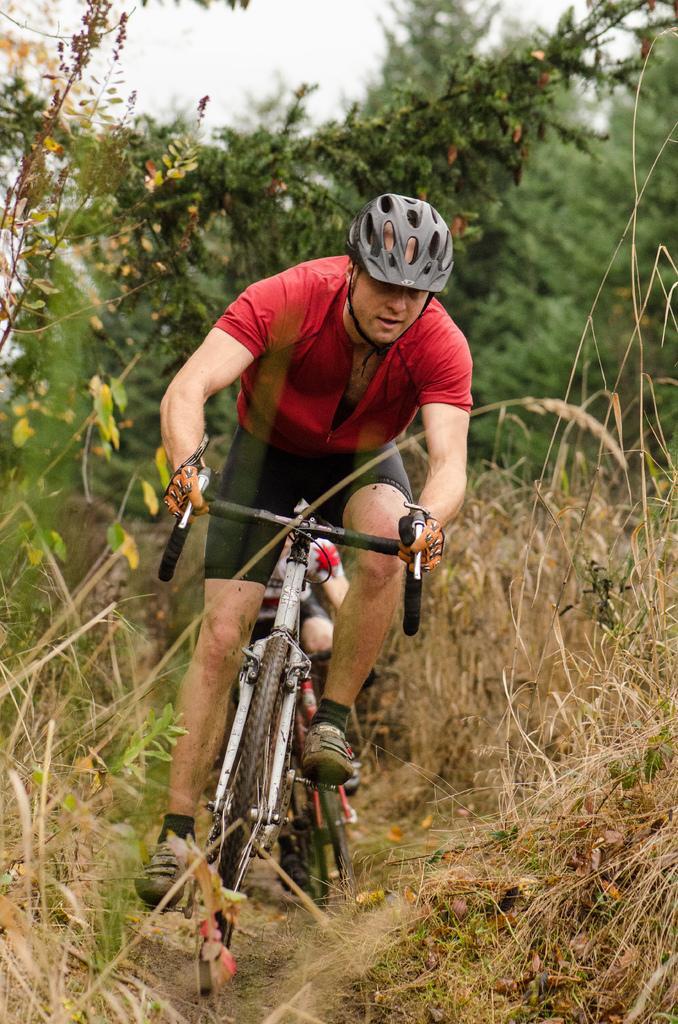Could you give a brief overview of what you see in this image? There is a person in red color t-shirt, sitting on a bicycle and cycling on the road. On both sides of the road, there are plants. In the background, there is another person cycling on the road, there are trees and there is sky. 